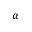<formula> <loc_0><loc_0><loc_500><loc_500>\alpha</formula> 